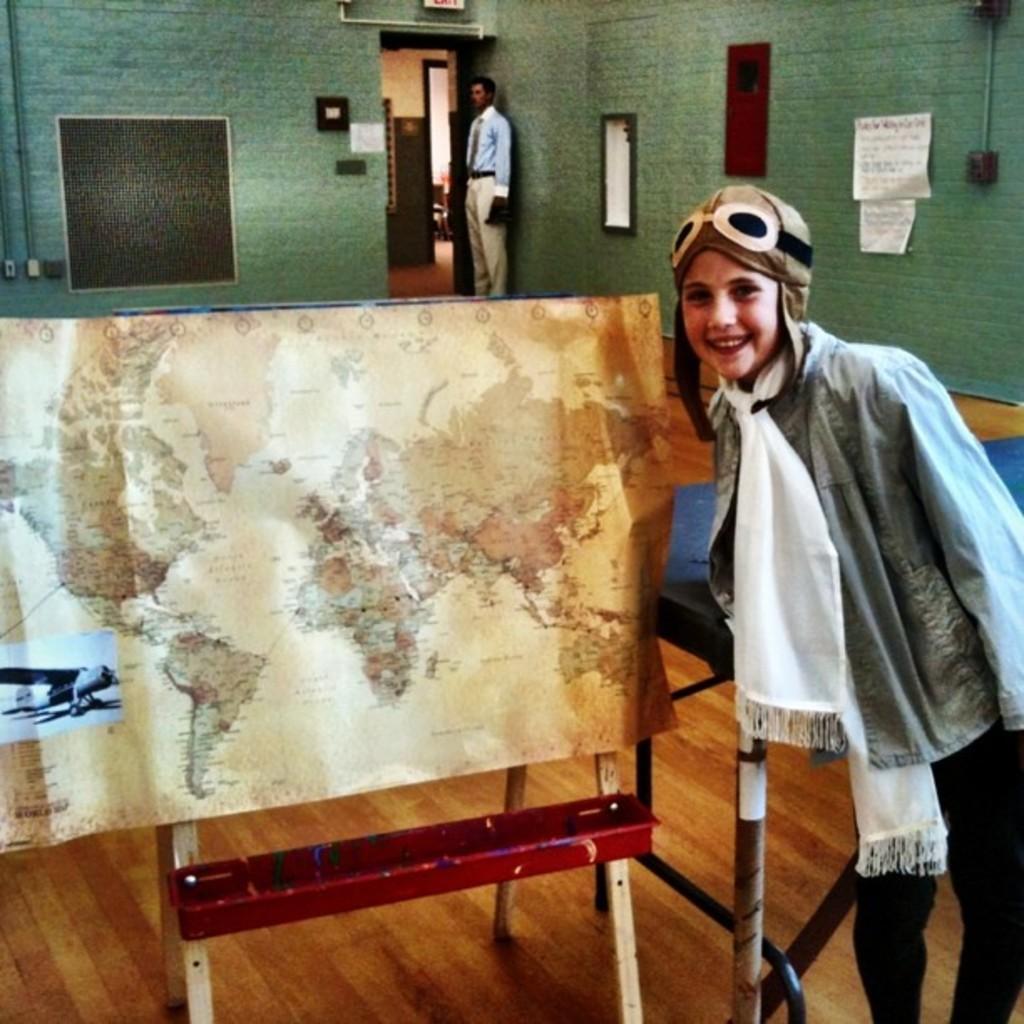In one or two sentences, can you explain what this image depicts? In this image there is a map which is on the stand , a person standing standing near the map, table, papers and a frame attached to the wall, another person standing,wall, pipes. 